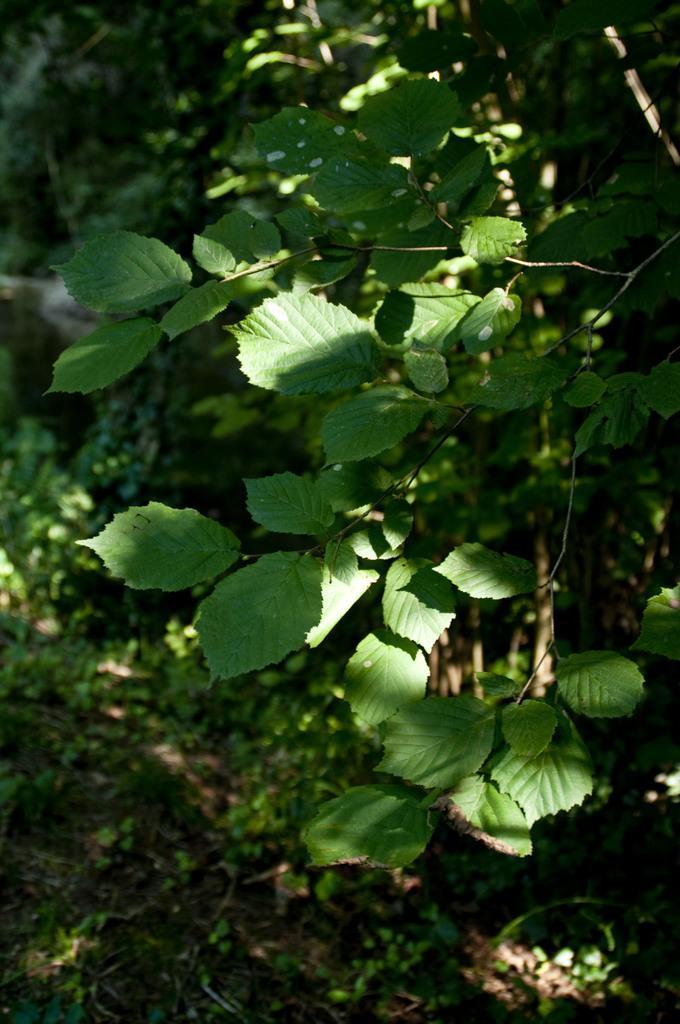Can you describe this image briefly? In this image we can see a group of plants. 